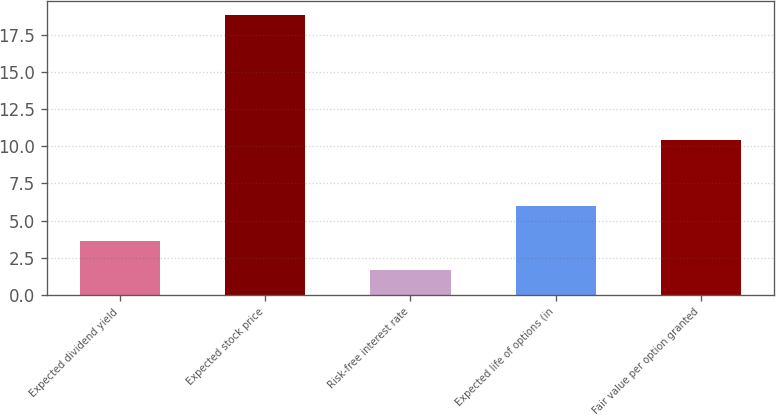Convert chart. <chart><loc_0><loc_0><loc_500><loc_500><bar_chart><fcel>Expected dividend yield<fcel>Expected stock price<fcel>Risk-free interest rate<fcel>Expected life of options (in<fcel>Fair value per option granted<nl><fcel>3.6<fcel>18.8<fcel>1.7<fcel>6<fcel>10.43<nl></chart> 